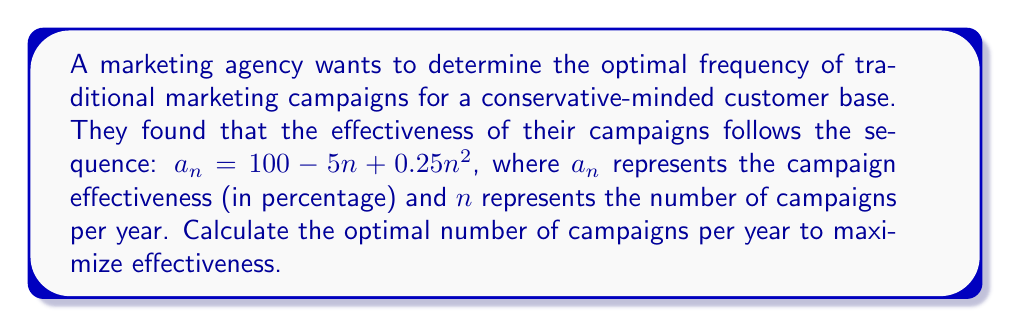Help me with this question. To find the optimal number of campaigns, we need to determine the maximum value of the sequence. This can be done by following these steps:

1. Recognize that the sequence $a_n = 100 - 5n + 0.25n^2$ is a quadratic function.

2. To find the maximum value of a quadratic function, we need to calculate its vertex. The vertex represents the highest point of the parabola.

3. For a quadratic function in the form $f(x) = ax^2 + bx + c$, the x-coordinate of the vertex is given by $x = -\frac{b}{2a}$.

4. In our case, $a = 0.25$, $b = -5$, and $c = 100$.

5. Substituting these values into the vertex formula:

   $$x = -\frac{-5}{2(0.25)} = \frac{5}{0.5} = 10$$

6. Since $n$ represents the number of campaigns and must be a whole number, we round 10 to the nearest integer.

7. Therefore, the optimal number of campaigns per year is 10.

8. To verify, we can calculate the effectiveness for 9, 10, and 11 campaigns:
   
   $a_9 = 100 - 5(9) + 0.25(9^2) = 100 - 45 + 20.25 = 75.25\%$
   $a_{10} = 100 - 5(10) + 0.25(10^2) = 100 - 50 + 25 = 75\%$
   $a_{11} = 100 - 5(11) + 0.25(11^2) = 100 - 55 + 30.25 = 74.25\%$

   This confirms that 10 campaigns yield the highest effectiveness.
Answer: 10 campaigns per year 